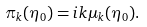Convert formula to latex. <formula><loc_0><loc_0><loc_500><loc_500>\pi _ { k } ( \eta _ { 0 } ) = i k \mu _ { k } ( \eta _ { 0 } ) .</formula> 